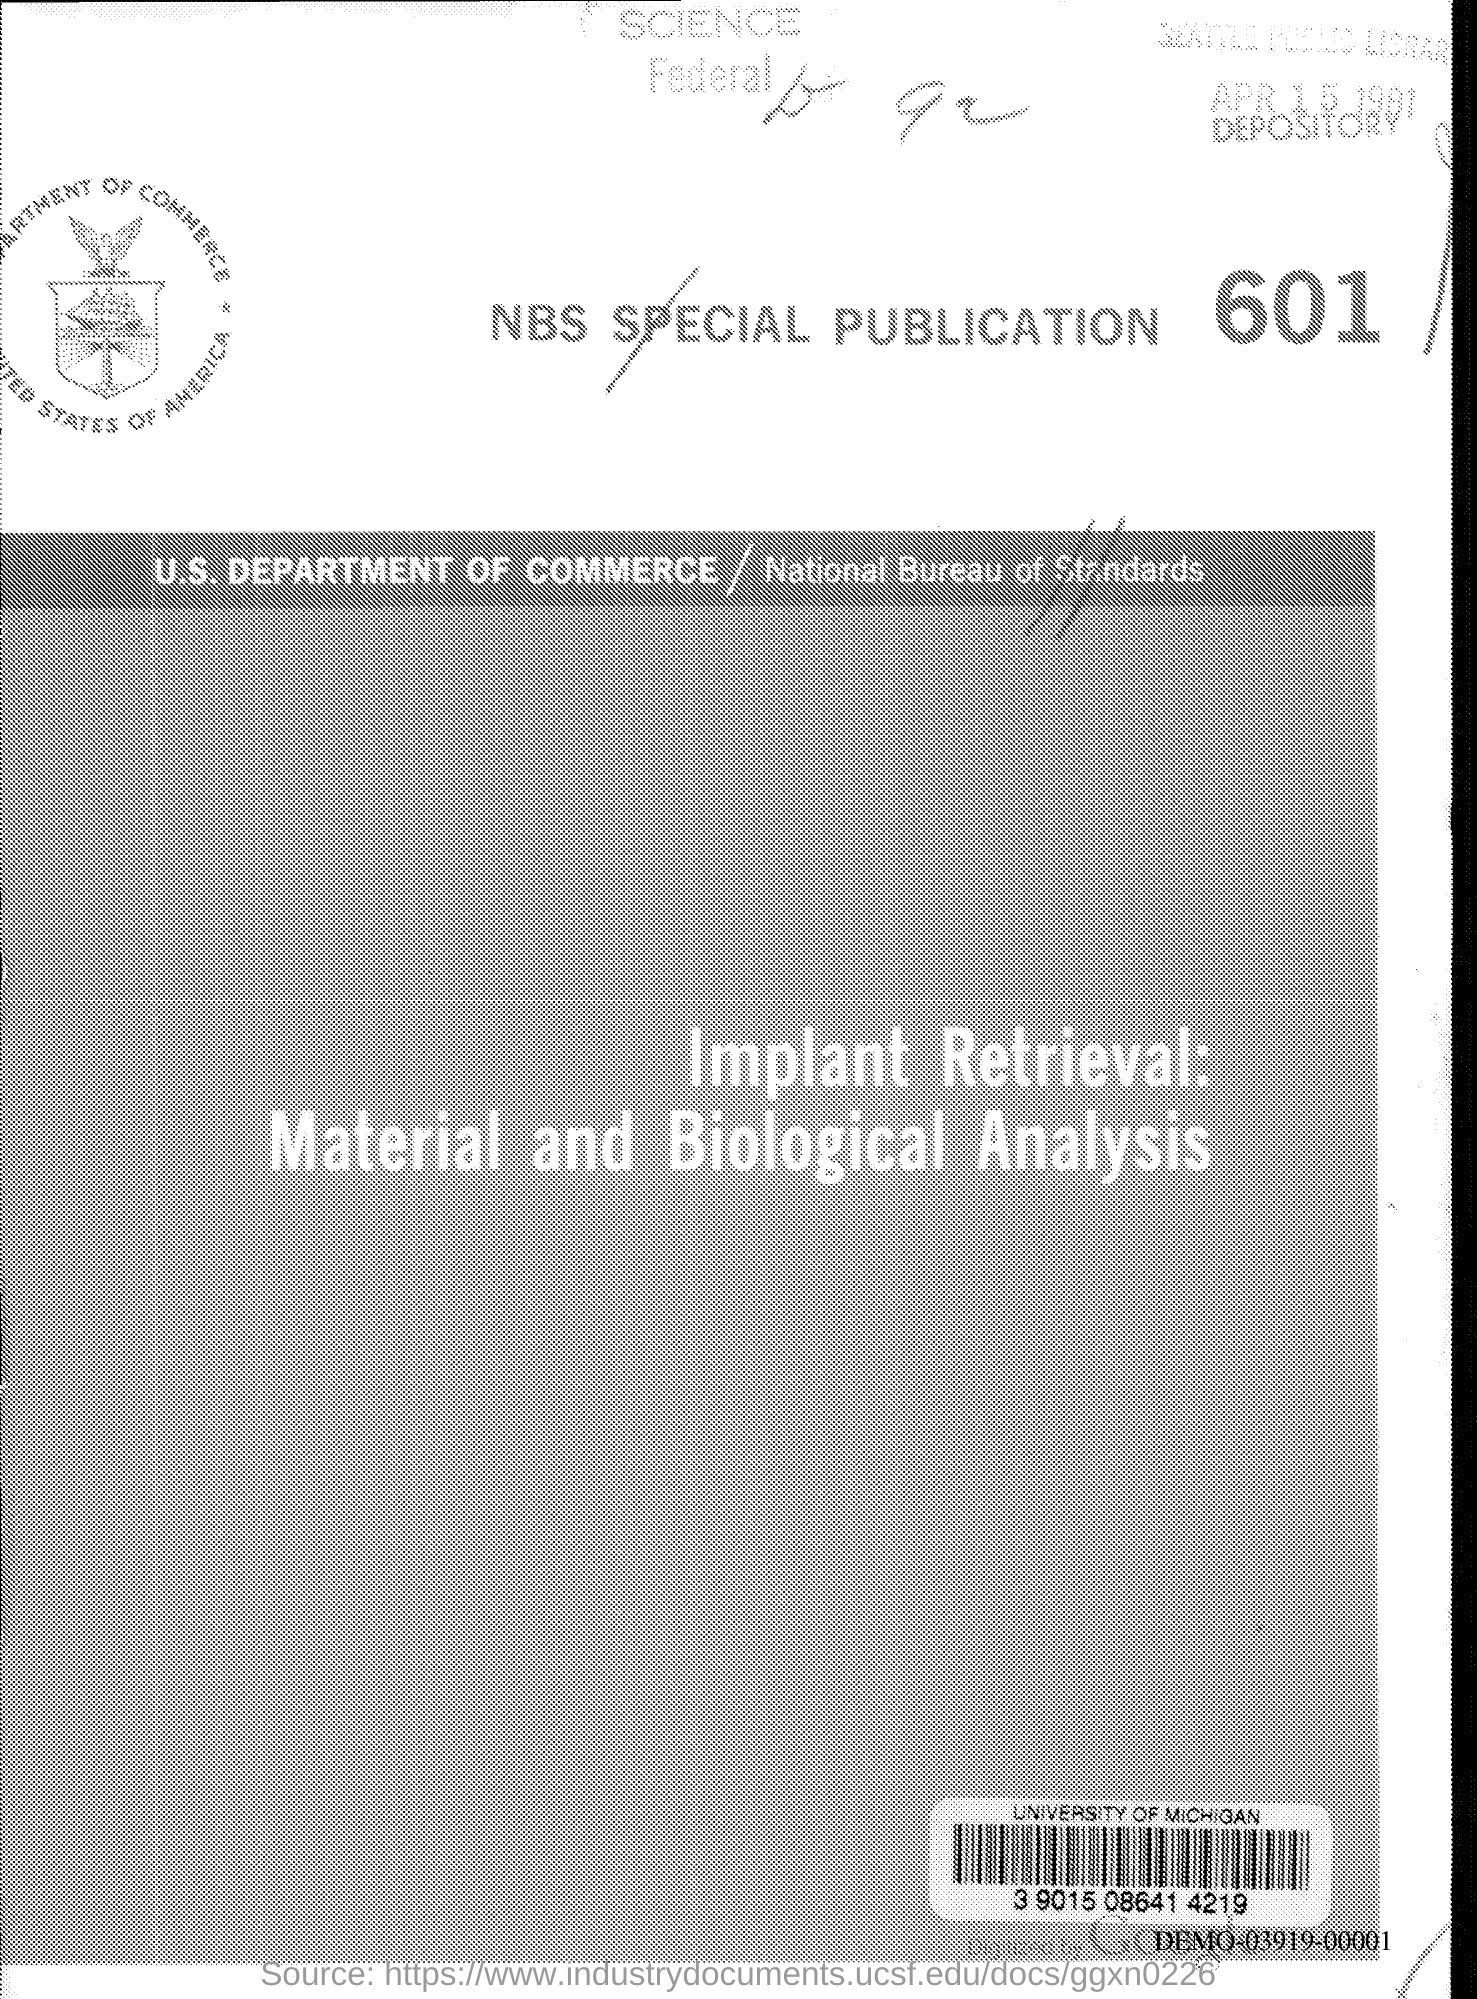Indicate a few pertinent items in this graphic. The NBS special publication number is 601.. 